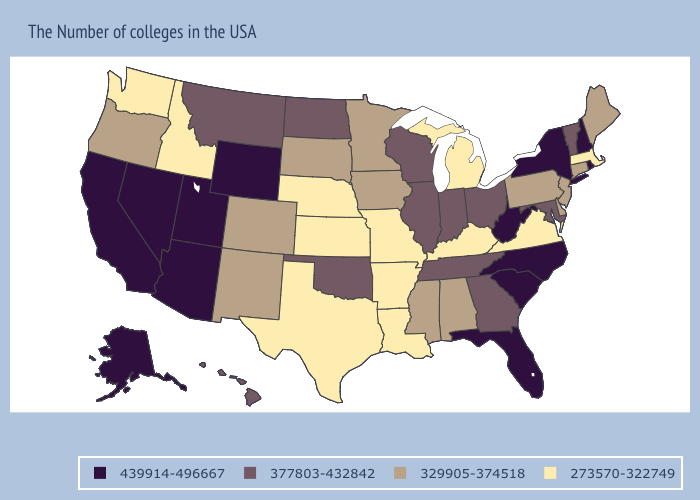Name the states that have a value in the range 329905-374518?
Keep it brief. Maine, Connecticut, New Jersey, Delaware, Pennsylvania, Alabama, Mississippi, Minnesota, Iowa, South Dakota, Colorado, New Mexico, Oregon. Name the states that have a value in the range 273570-322749?
Quick response, please. Massachusetts, Virginia, Michigan, Kentucky, Louisiana, Missouri, Arkansas, Kansas, Nebraska, Texas, Idaho, Washington. Does Hawaii have the lowest value in the West?
Short answer required. No. Name the states that have a value in the range 439914-496667?
Answer briefly. Rhode Island, New Hampshire, New York, North Carolina, South Carolina, West Virginia, Florida, Wyoming, Utah, Arizona, Nevada, California, Alaska. Name the states that have a value in the range 377803-432842?
Quick response, please. Vermont, Maryland, Ohio, Georgia, Indiana, Tennessee, Wisconsin, Illinois, Oklahoma, North Dakota, Montana, Hawaii. What is the value of Vermont?
Answer briefly. 377803-432842. Which states have the lowest value in the South?
Answer briefly. Virginia, Kentucky, Louisiana, Arkansas, Texas. What is the value of Utah?
Write a very short answer. 439914-496667. Which states hav the highest value in the MidWest?
Be succinct. Ohio, Indiana, Wisconsin, Illinois, North Dakota. What is the value of Wyoming?
Be succinct. 439914-496667. What is the value of Kansas?
Give a very brief answer. 273570-322749. Among the states that border Wyoming , does Utah have the highest value?
Write a very short answer. Yes. Among the states that border Colorado , which have the highest value?
Quick response, please. Wyoming, Utah, Arizona. Does Massachusetts have the lowest value in the USA?
Short answer required. Yes. Name the states that have a value in the range 377803-432842?
Write a very short answer. Vermont, Maryland, Ohio, Georgia, Indiana, Tennessee, Wisconsin, Illinois, Oklahoma, North Dakota, Montana, Hawaii. 